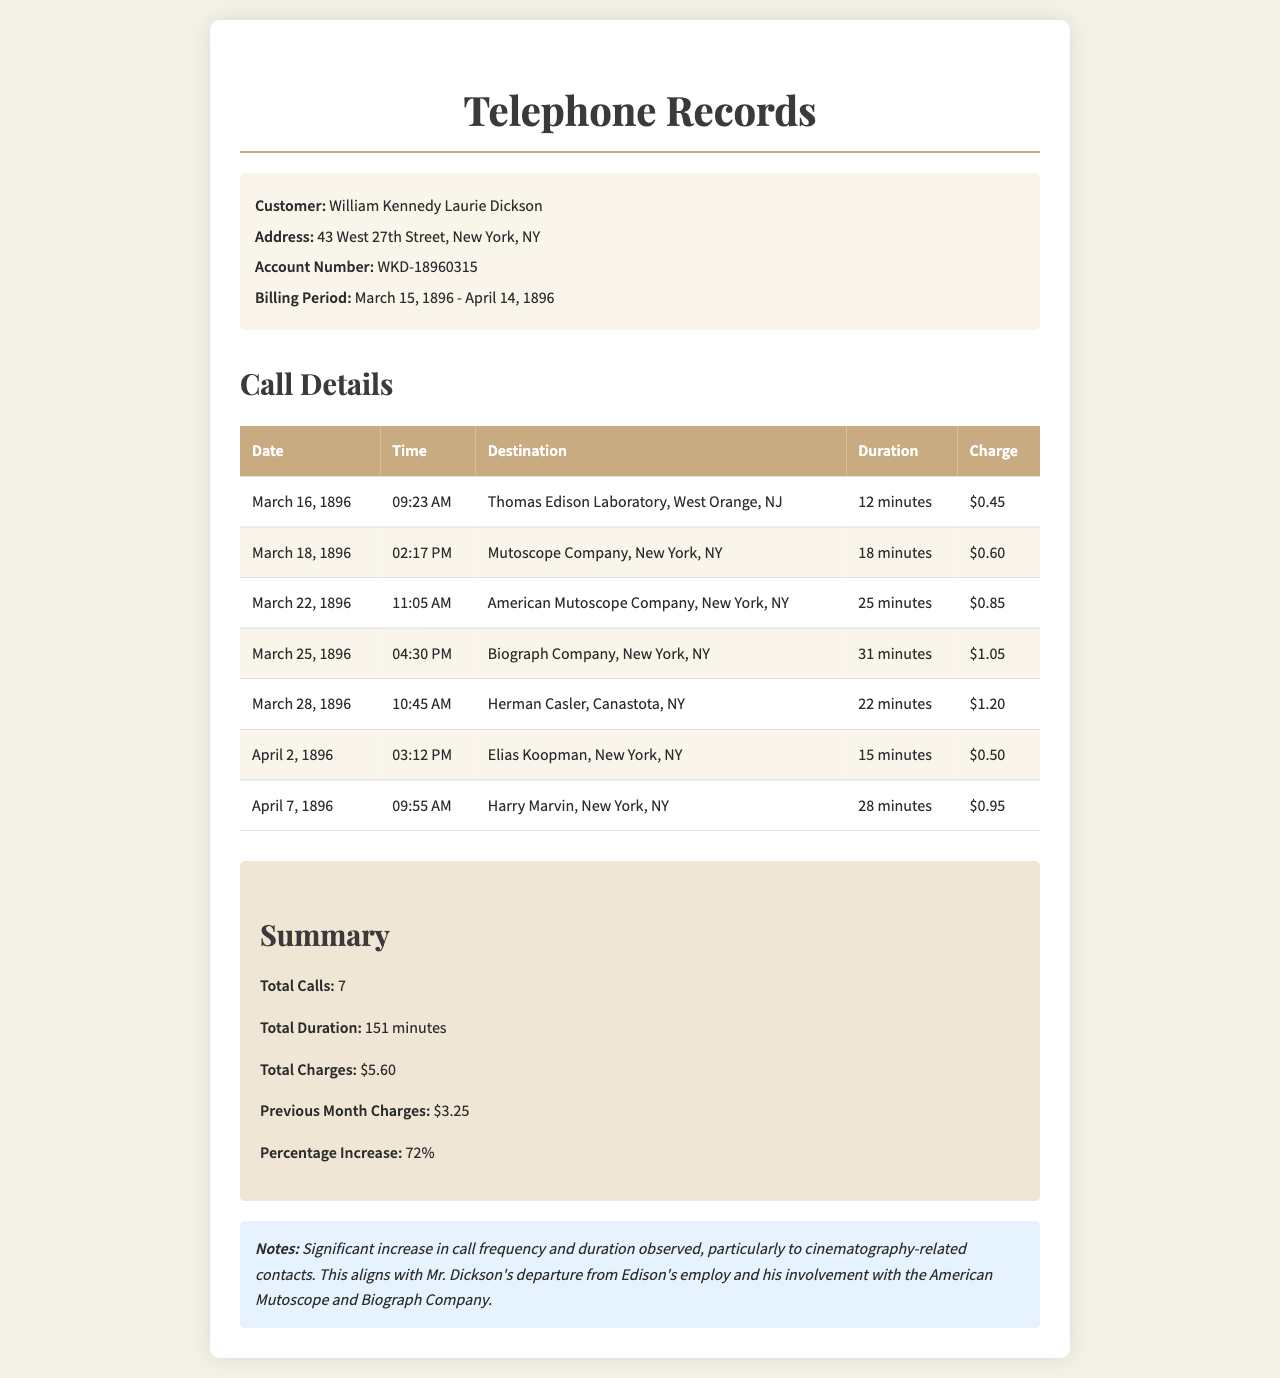what is the billing period? The billing period is defined by the dates provided in the document, which are March 15, 1896 to April 14, 1896.
Answer: March 15, 1896 - April 14, 1896 how many calls were made during this period? The total number of calls is summarized in the document, stating that there were 7 calls in total.
Answer: 7 what was the total duration of calls? The total duration is calculated and included in the summary section of the document, which indicates it sums up to 151 minutes.
Answer: 151 minutes to whom was the longest call made? The duration of each call helps identify which call was the longest, which was made to the Biograph Company for 31 minutes.
Answer: Biograph Company what percentage increase in charges was noted? The document indicates the percentage increase in charges compared to the previous month, stating a 72% increase.
Answer: 72% who is the customer listed in the document? The customer’s name is clearly stated at the beginning of the document.
Answer: William Kennedy Laurie Dickson which company was contacted on April 2, 1896? The call details list the destination of the call made on April 2, 1896, which is Elias Koopman in New York, NY.
Answer: Elias Koopman, New York, NY what is the charge for the call to Thomas Edison Laboratory? The charges for each call are itemized, showing $0.45 for the call to Thomas Edison Laboratory.
Answer: $0.45 what is the previous month’s charges? The document provides a summary that includes the charges from the previous month, noted as $3.25.
Answer: $3.25 